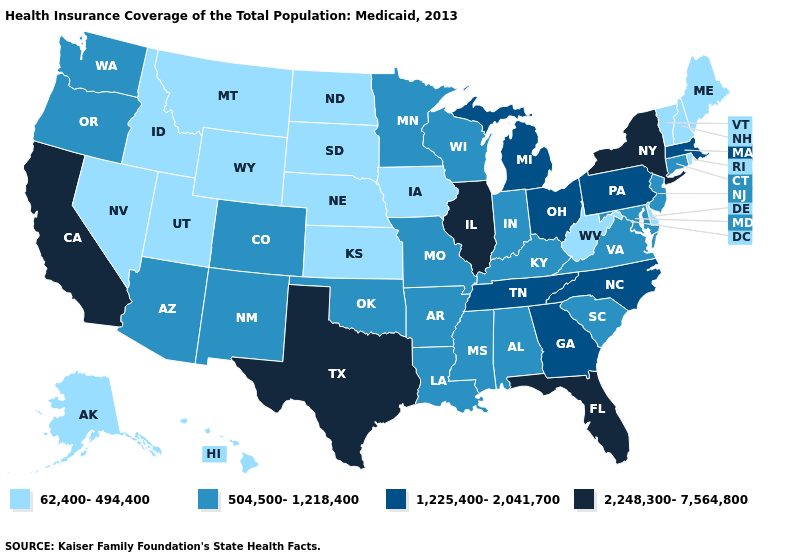Does the first symbol in the legend represent the smallest category?
Write a very short answer. Yes. Name the states that have a value in the range 504,500-1,218,400?
Be succinct. Alabama, Arizona, Arkansas, Colorado, Connecticut, Indiana, Kentucky, Louisiana, Maryland, Minnesota, Mississippi, Missouri, New Jersey, New Mexico, Oklahoma, Oregon, South Carolina, Virginia, Washington, Wisconsin. Name the states that have a value in the range 504,500-1,218,400?
Short answer required. Alabama, Arizona, Arkansas, Colorado, Connecticut, Indiana, Kentucky, Louisiana, Maryland, Minnesota, Mississippi, Missouri, New Jersey, New Mexico, Oklahoma, Oregon, South Carolina, Virginia, Washington, Wisconsin. What is the highest value in the Northeast ?
Keep it brief. 2,248,300-7,564,800. What is the value of Ohio?
Be succinct. 1,225,400-2,041,700. Among the states that border Kansas , does Nebraska have the lowest value?
Concise answer only. Yes. Name the states that have a value in the range 2,248,300-7,564,800?
Write a very short answer. California, Florida, Illinois, New York, Texas. Which states have the highest value in the USA?
Be succinct. California, Florida, Illinois, New York, Texas. Name the states that have a value in the range 1,225,400-2,041,700?
Write a very short answer. Georgia, Massachusetts, Michigan, North Carolina, Ohio, Pennsylvania, Tennessee. What is the highest value in the USA?
Write a very short answer. 2,248,300-7,564,800. What is the value of Massachusetts?
Quick response, please. 1,225,400-2,041,700. Among the states that border Massachusetts , which have the lowest value?
Short answer required. New Hampshire, Rhode Island, Vermont. How many symbols are there in the legend?
Be succinct. 4. Does the first symbol in the legend represent the smallest category?
Keep it brief. Yes. What is the highest value in the USA?
Write a very short answer. 2,248,300-7,564,800. 